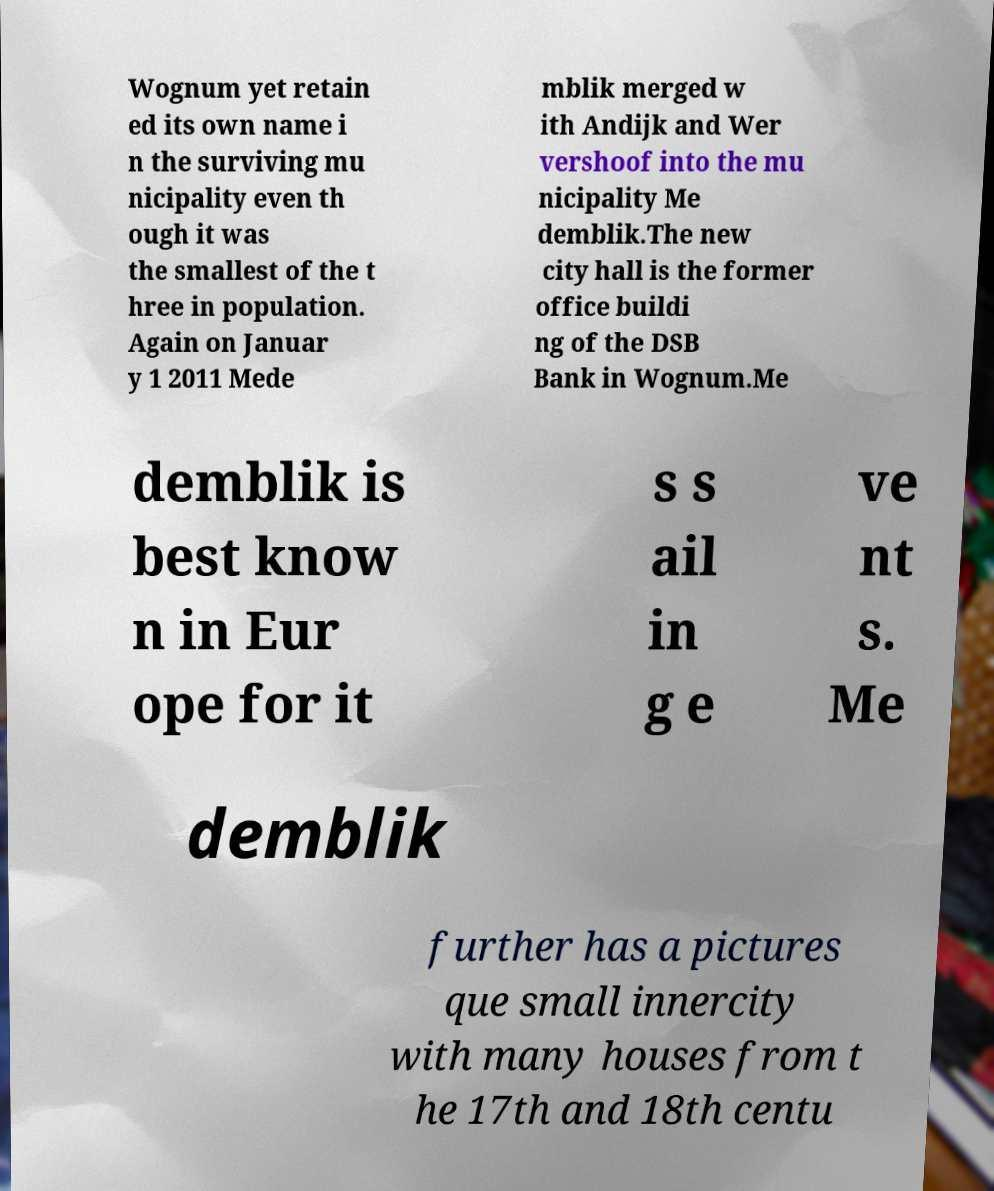Can you read and provide the text displayed in the image?This photo seems to have some interesting text. Can you extract and type it out for me? Wognum yet retain ed its own name i n the surviving mu nicipality even th ough it was the smallest of the t hree in population. Again on Januar y 1 2011 Mede mblik merged w ith Andijk and Wer vershoof into the mu nicipality Me demblik.The new city hall is the former office buildi ng of the DSB Bank in Wognum.Me demblik is best know n in Eur ope for it s s ail in g e ve nt s. Me demblik further has a pictures que small innercity with many houses from t he 17th and 18th centu 